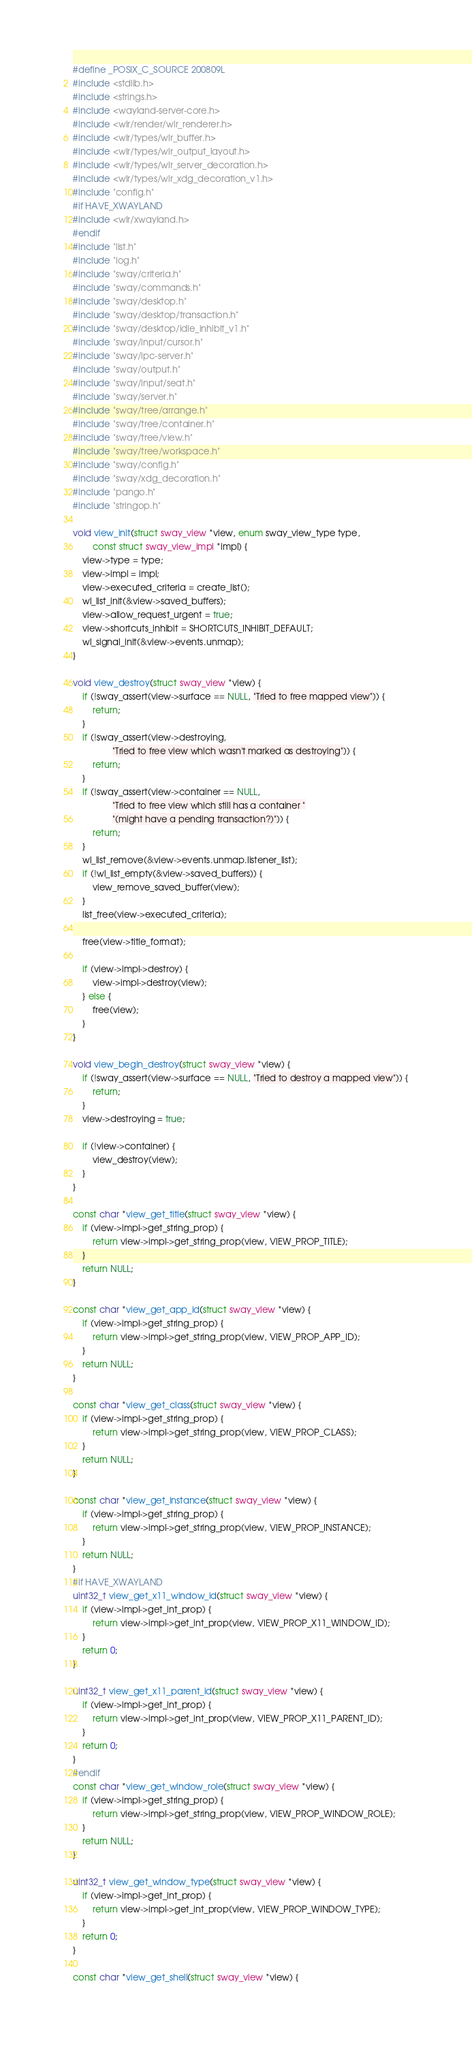<code> <loc_0><loc_0><loc_500><loc_500><_C_>#define _POSIX_C_SOURCE 200809L
#include <stdlib.h>
#include <strings.h>
#include <wayland-server-core.h>
#include <wlr/render/wlr_renderer.h>
#include <wlr/types/wlr_buffer.h>
#include <wlr/types/wlr_output_layout.h>
#include <wlr/types/wlr_server_decoration.h>
#include <wlr/types/wlr_xdg_decoration_v1.h>
#include "config.h"
#if HAVE_XWAYLAND
#include <wlr/xwayland.h>
#endif
#include "list.h"
#include "log.h"
#include "sway/criteria.h"
#include "sway/commands.h"
#include "sway/desktop.h"
#include "sway/desktop/transaction.h"
#include "sway/desktop/idle_inhibit_v1.h"
#include "sway/input/cursor.h"
#include "sway/ipc-server.h"
#include "sway/output.h"
#include "sway/input/seat.h"
#include "sway/server.h"
#include "sway/tree/arrange.h"
#include "sway/tree/container.h"
#include "sway/tree/view.h"
#include "sway/tree/workspace.h"
#include "sway/config.h"
#include "sway/xdg_decoration.h"
#include "pango.h"
#include "stringop.h"

void view_init(struct sway_view *view, enum sway_view_type type,
		const struct sway_view_impl *impl) {
	view->type = type;
	view->impl = impl;
	view->executed_criteria = create_list();
	wl_list_init(&view->saved_buffers);
	view->allow_request_urgent = true;
	view->shortcuts_inhibit = SHORTCUTS_INHIBIT_DEFAULT;
	wl_signal_init(&view->events.unmap);
}

void view_destroy(struct sway_view *view) {
	if (!sway_assert(view->surface == NULL, "Tried to free mapped view")) {
		return;
	}
	if (!sway_assert(view->destroying,
				"Tried to free view which wasn't marked as destroying")) {
		return;
	}
	if (!sway_assert(view->container == NULL,
				"Tried to free view which still has a container "
				"(might have a pending transaction?)")) {
		return;
	}
	wl_list_remove(&view->events.unmap.listener_list);
	if (!wl_list_empty(&view->saved_buffers)) {
		view_remove_saved_buffer(view);
	}
	list_free(view->executed_criteria);

	free(view->title_format);

	if (view->impl->destroy) {
		view->impl->destroy(view);
	} else {
		free(view);
	}
}

void view_begin_destroy(struct sway_view *view) {
	if (!sway_assert(view->surface == NULL, "Tried to destroy a mapped view")) {
		return;
	}
	view->destroying = true;

	if (!view->container) {
		view_destroy(view);
	}
}

const char *view_get_title(struct sway_view *view) {
	if (view->impl->get_string_prop) {
		return view->impl->get_string_prop(view, VIEW_PROP_TITLE);
	}
	return NULL;
}

const char *view_get_app_id(struct sway_view *view) {
	if (view->impl->get_string_prop) {
		return view->impl->get_string_prop(view, VIEW_PROP_APP_ID);
	}
	return NULL;
}

const char *view_get_class(struct sway_view *view) {
	if (view->impl->get_string_prop) {
		return view->impl->get_string_prop(view, VIEW_PROP_CLASS);
	}
	return NULL;
}

const char *view_get_instance(struct sway_view *view) {
	if (view->impl->get_string_prop) {
		return view->impl->get_string_prop(view, VIEW_PROP_INSTANCE);
	}
	return NULL;
}
#if HAVE_XWAYLAND
uint32_t view_get_x11_window_id(struct sway_view *view) {
	if (view->impl->get_int_prop) {
		return view->impl->get_int_prop(view, VIEW_PROP_X11_WINDOW_ID);
	}
	return 0;
}

uint32_t view_get_x11_parent_id(struct sway_view *view) {
	if (view->impl->get_int_prop) {
		return view->impl->get_int_prop(view, VIEW_PROP_X11_PARENT_ID);
	}
	return 0;
}
#endif
const char *view_get_window_role(struct sway_view *view) {
	if (view->impl->get_string_prop) {
		return view->impl->get_string_prop(view, VIEW_PROP_WINDOW_ROLE);
	}
	return NULL;
}

uint32_t view_get_window_type(struct sway_view *view) {
	if (view->impl->get_int_prop) {
		return view->impl->get_int_prop(view, VIEW_PROP_WINDOW_TYPE);
	}
	return 0;
}

const char *view_get_shell(struct sway_view *view) {</code> 